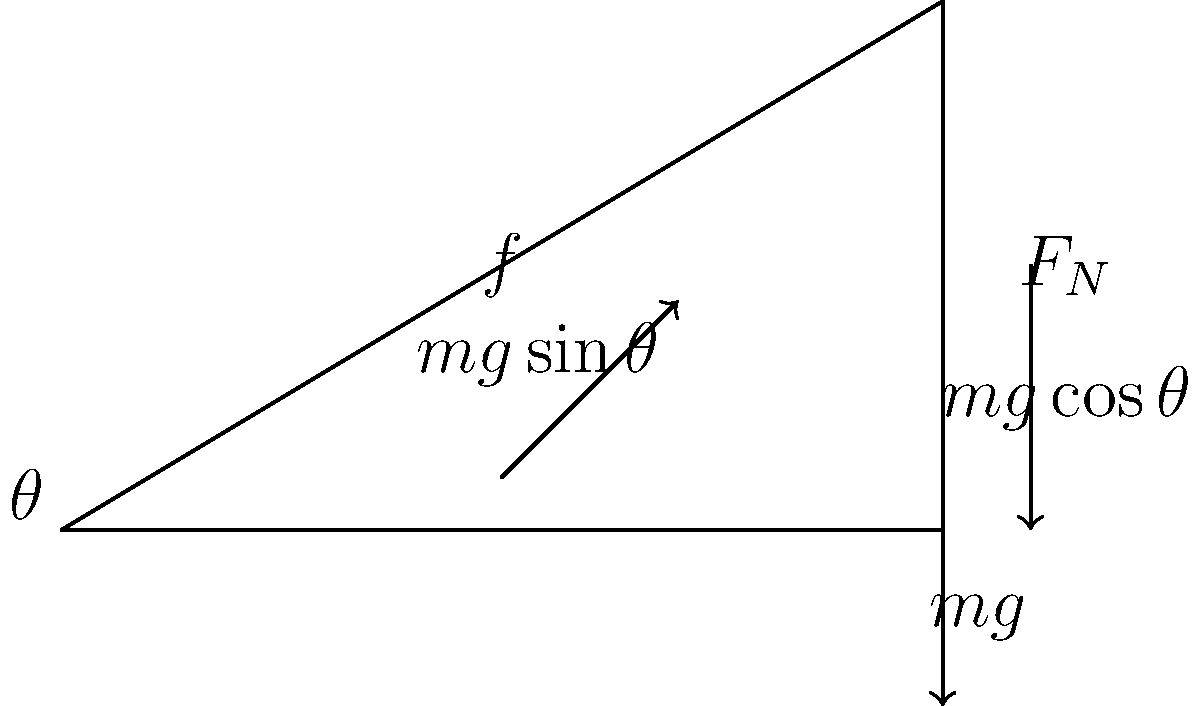As a government official overseeing safety regulations for construction sites, you need to understand the forces acting on objects on inclined planes. Consider a block of mass $m$ resting on an inclined plane with angle $\theta$ to the horizontal. If the coefficient of static friction between the block and the plane is $\mu_s$, what is the maximum angle $\theta_{max}$ at which the block will remain stationary on the inclined plane? To solve this problem, let's follow these steps:

1) The forces acting on the block are:
   - Weight ($mg$) acting downwards
   - Normal force ($F_N$) perpendicular to the plane
   - Friction force ($f$) parallel to the plane, opposing motion

2) We can resolve the weight into components:
   - Parallel to the plane: $mg\sin\theta$
   - Perpendicular to the plane: $mg\cos\theta$

3) For the block to remain stationary, the friction force must equal the component of weight parallel to the plane:

   $f = mg\sin\theta$

4) The maximum friction force is given by:

   $f_{max} = \mu_s F_N$

5) The normal force is equal to the component of weight perpendicular to the plane:

   $F_N = mg\cos\theta$

6) At the maximum angle, the friction force will be at its maximum:

   $\mu_s mg\cos\theta = mg\sin\theta$

7) Simplifying:

   $\mu_s = \tan\theta$

8) Therefore, the maximum angle is:

   $\theta_{max} = \arctan(\mu_s)$

This angle represents the steepest incline on which the block will remain stationary, crucial for determining safe slopes in construction sites.
Answer: $\theta_{max} = \arctan(\mu_s)$ 